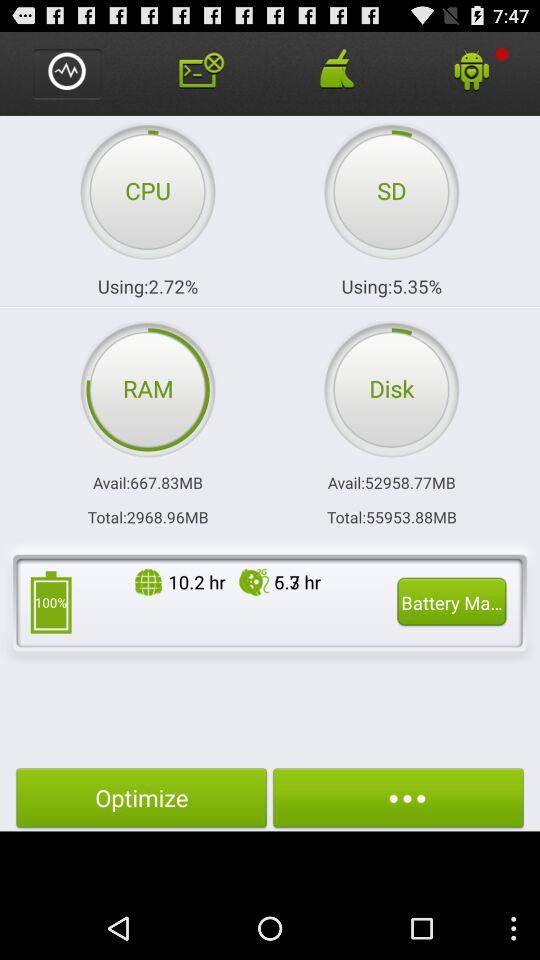How many MB of RAM are available? There are 667.83 MB of RAM available. 